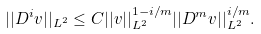<formula> <loc_0><loc_0><loc_500><loc_500>| | D ^ { i } v | | _ { L ^ { 2 } } \leq C | | v | | _ { L ^ { 2 } } ^ { 1 - i / m } | | D ^ { m } v | | _ { L ^ { 2 } } ^ { i / m } .</formula> 